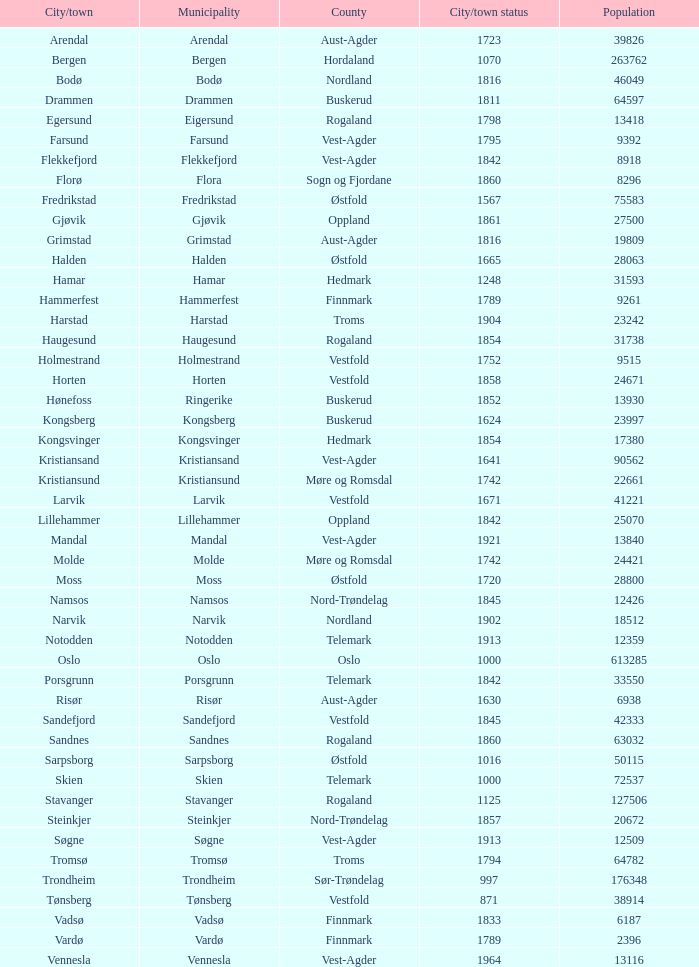Which local government area has a population of 24421? Molde. 